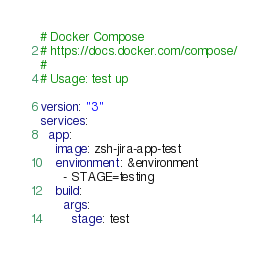<code> <loc_0><loc_0><loc_500><loc_500><_YAML_># Docker Compose
# https://docs.docker.com/compose/
#
# Usage: test up

version: "3"
services:
  app:
    image: zsh-jira-app-test
    environment: &environment
      - STAGE=testing
    build:
      args:
        stage: test
</code> 